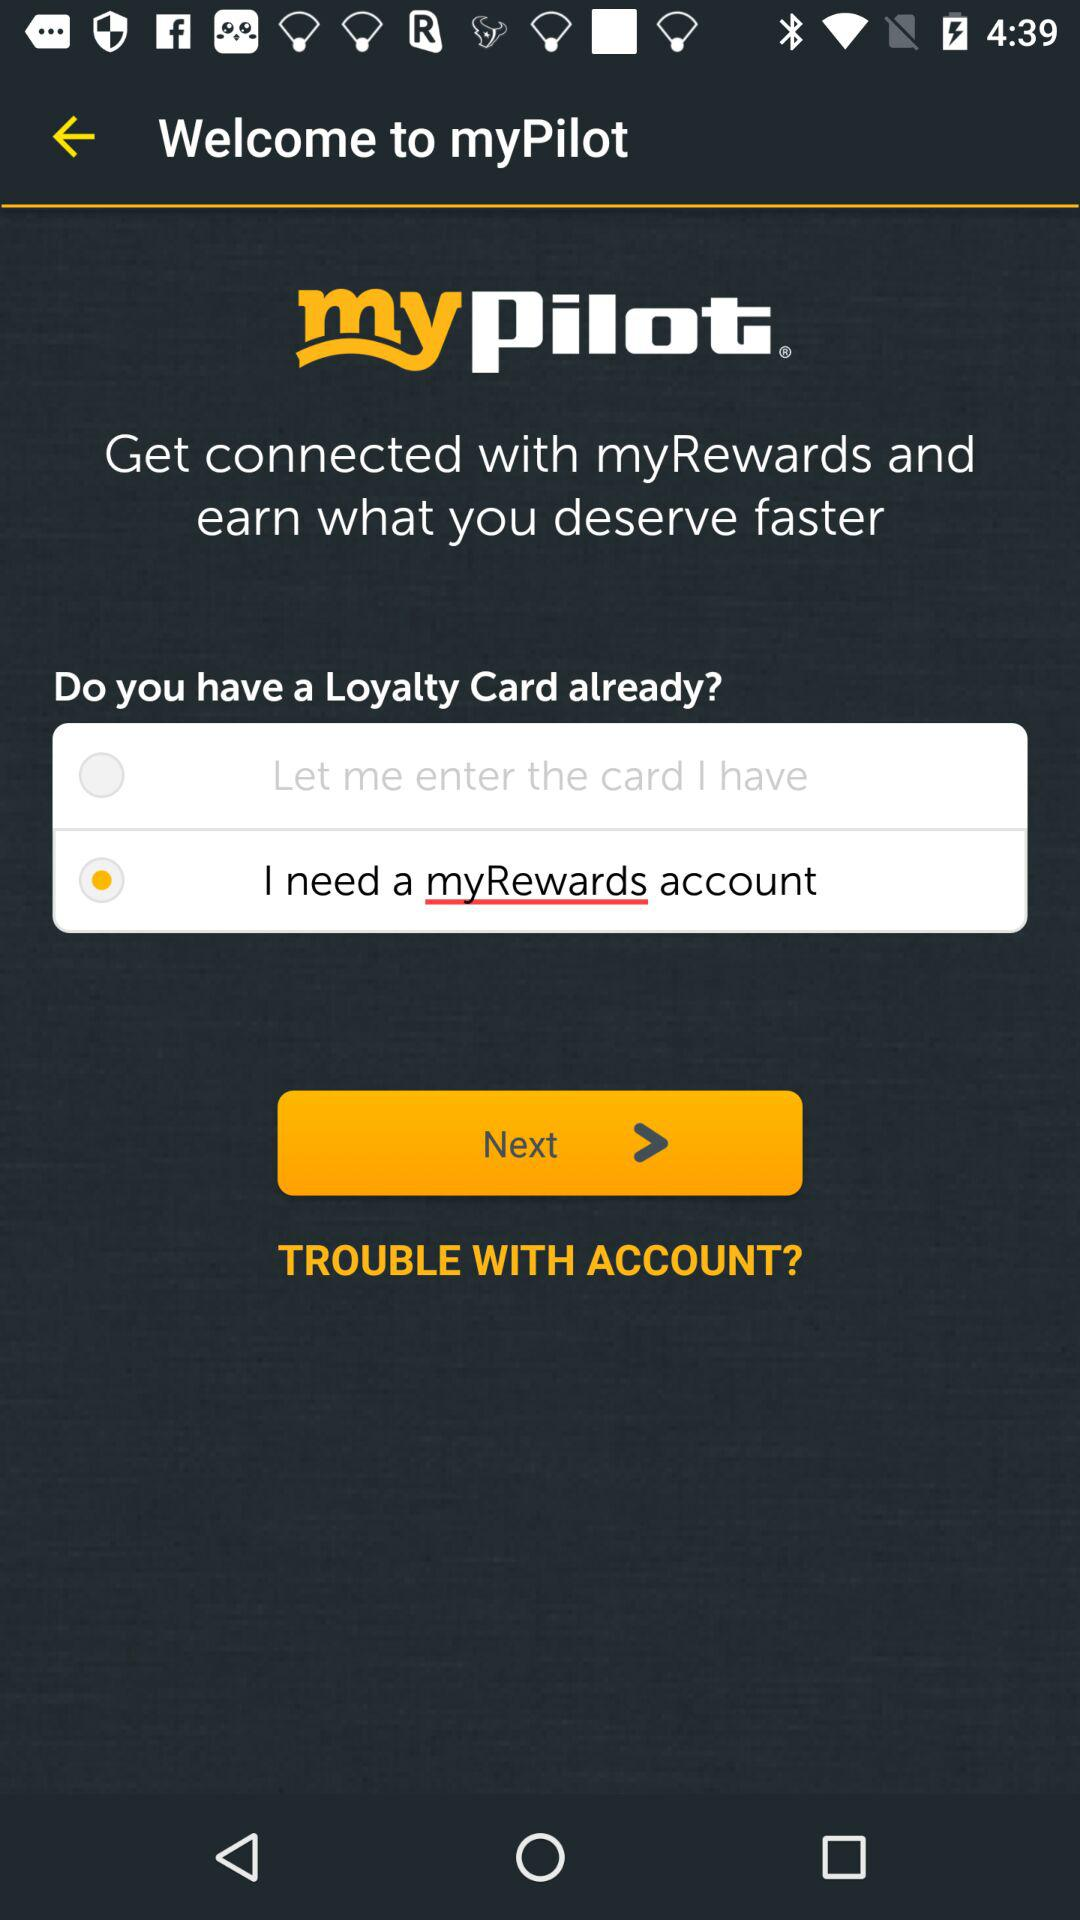What is the status of the "Let me enter the card I have"? The status of the "Let me enter the card I have" is "off". 